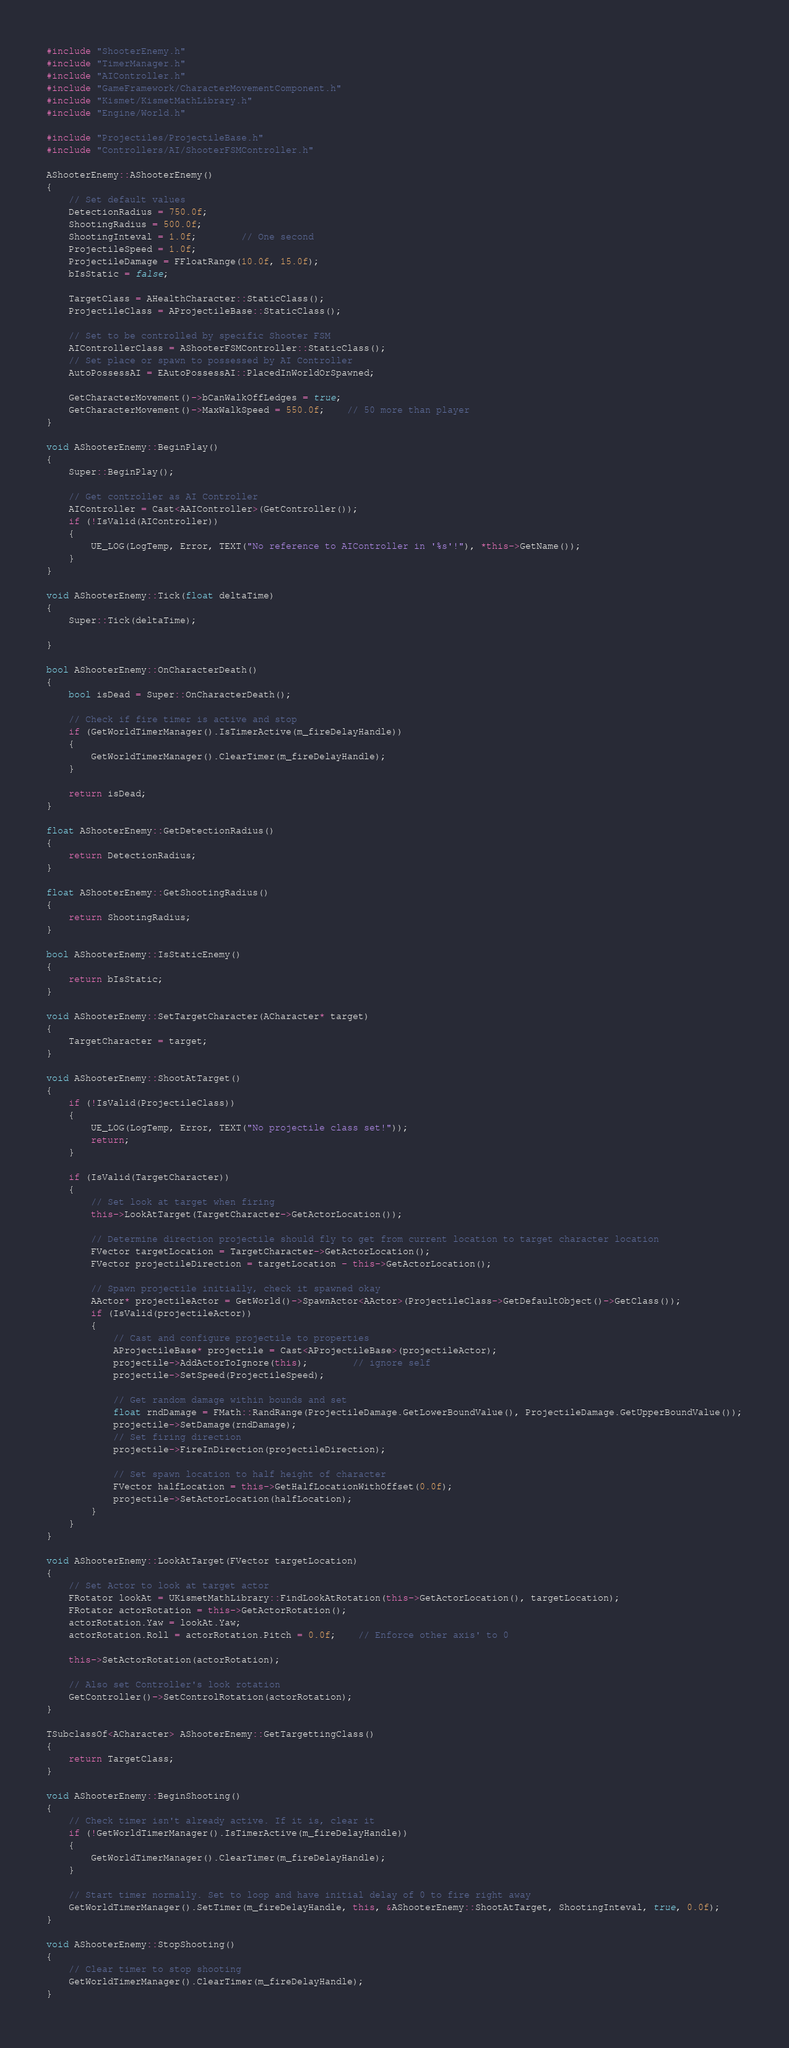<code> <loc_0><loc_0><loc_500><loc_500><_C++_>


#include "ShooterEnemy.h"
#include "TimerManager.h"
#include "AIController.h"
#include "GameFramework/CharacterMovementComponent.h"
#include "Kismet/KismetMathLibrary.h"
#include "Engine/World.h"

#include "Projectiles/ProjectileBase.h"
#include "Controllers/AI/ShooterFSMController.h"

AShooterEnemy::AShooterEnemy()
{
	// Set default values
	DetectionRadius = 750.0f;
	ShootingRadius = 500.0f;
	ShootingInteval = 1.0f;		// One second
	ProjectileSpeed = 1.0f;
	ProjectileDamage = FFloatRange(10.0f, 15.0f);
	bIsStatic = false;

	TargetClass = AHealthCharacter::StaticClass();
	ProjectileClass = AProjectileBase::StaticClass();
	
	// Set to be controlled by specific Shooter FSM
	AIControllerClass = AShooterFSMController::StaticClass();
	// Set place or spawn to possessed by AI Controller
	AutoPossessAI = EAutoPossessAI::PlacedInWorldOrSpawned;

	GetCharacterMovement()->bCanWalkOffLedges = true;
	GetCharacterMovement()->MaxWalkSpeed = 550.0f;	// 50 more than player
}

void AShooterEnemy::BeginPlay()
{
	Super::BeginPlay();

	// Get controller as AI Controller
	AIController = Cast<AAIController>(GetController());
	if (!IsValid(AIController))
	{
		UE_LOG(LogTemp, Error, TEXT("No reference to AIController in '%s'!"), *this->GetName());
	}
}

void AShooterEnemy::Tick(float deltaTime)
{
	Super::Tick(deltaTime);

}

bool AShooterEnemy::OnCharacterDeath()
{
	bool isDead = Super::OnCharacterDeath();

	// Check if fire timer is active and stop
	if (GetWorldTimerManager().IsTimerActive(m_fireDelayHandle))
	{
		GetWorldTimerManager().ClearTimer(m_fireDelayHandle);
	}

	return isDead;
}

float AShooterEnemy::GetDetectionRadius()
{
	return DetectionRadius;
}

float AShooterEnemy::GetShootingRadius()
{
	return ShootingRadius;
}

bool AShooterEnemy::IsStaticEnemy()
{
	return bIsStatic;
}

void AShooterEnemy::SetTargetCharacter(ACharacter* target)
{
	TargetCharacter = target;
}

void AShooterEnemy::ShootAtTarget()
{
	if (!IsValid(ProjectileClass))
	{
		UE_LOG(LogTemp, Error, TEXT("No projectile class set!"));
		return;
	}
	 
	if (IsValid(TargetCharacter))
	{
		// Set look at target when firing
		this->LookAtTarget(TargetCharacter->GetActorLocation());
		
		// Determine direction projectile should fly to get from current location to target character location
		FVector targetLocation = TargetCharacter->GetActorLocation();
		FVector projectileDirection = targetLocation - this->GetActorLocation();
	
		// Spawn projectile initially, check it spawned okay
		AActor* projectileActor = GetWorld()->SpawnActor<AActor>(ProjectileClass->GetDefaultObject()->GetClass());
		if (IsValid(projectileActor))
		{
			// Cast and configure projectile to properties
			AProjectileBase* projectile = Cast<AProjectileBase>(projectileActor);
			projectile->AddActorToIgnore(this);		// ignore self
			projectile->SetSpeed(ProjectileSpeed);

			// Get random damage within bounds and set
			float rndDamage = FMath::RandRange(ProjectileDamage.GetLowerBoundValue(), ProjectileDamage.GetUpperBoundValue());
			projectile->SetDamage(rndDamage);
			// Set firing direction
			projectile->FireInDirection(projectileDirection);

			// Set spawn location to half height of character
			FVector halfLocation = this->GetHalfLocationWithOffset(0.0f);
			projectile->SetActorLocation(halfLocation);
		}
	}
}

void AShooterEnemy::LookAtTarget(FVector targetLocation)
{
	// Set Actor to look at target actor
	FRotator lookAt = UKismetMathLibrary::FindLookAtRotation(this->GetActorLocation(), targetLocation);
	FRotator actorRotation = this->GetActorRotation();
	actorRotation.Yaw = lookAt.Yaw;
	actorRotation.Roll = actorRotation.Pitch = 0.0f;	// Enforce other axis' to 0

	this->SetActorRotation(actorRotation);

	// Also set Controller's look rotation
	GetController()->SetControlRotation(actorRotation);
}

TSubclassOf<ACharacter> AShooterEnemy::GetTargettingClass()
{
	return TargetClass;
}

void AShooterEnemy::BeginShooting()
{
	// Check timer isn't already active. If it is, clear it
	if (!GetWorldTimerManager().IsTimerActive(m_fireDelayHandle))
	{
		GetWorldTimerManager().ClearTimer(m_fireDelayHandle);
	}

	// Start timer normally. Set to loop and have initial delay of 0 to fire right away
	GetWorldTimerManager().SetTimer(m_fireDelayHandle, this, &AShooterEnemy::ShootAtTarget, ShootingInteval, true, 0.0f);
}

void AShooterEnemy::StopShooting()
{
	// Clear timer to stop shooting
	GetWorldTimerManager().ClearTimer(m_fireDelayHandle);
}
</code> 